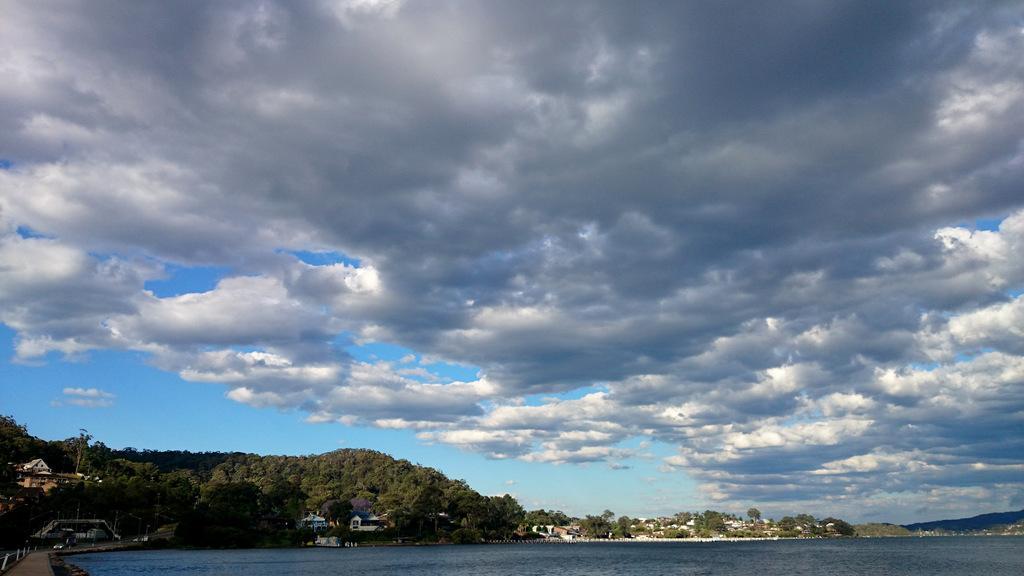Can you describe this image briefly? In this picture I can see trees, buildings and I can see water and a blue cloudy sky. 